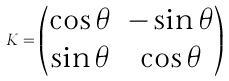<formula> <loc_0><loc_0><loc_500><loc_500>K = \begin{pmatrix} \cos \theta & - \sin \theta \\ \sin \theta & \cos \theta \end{pmatrix}</formula> 